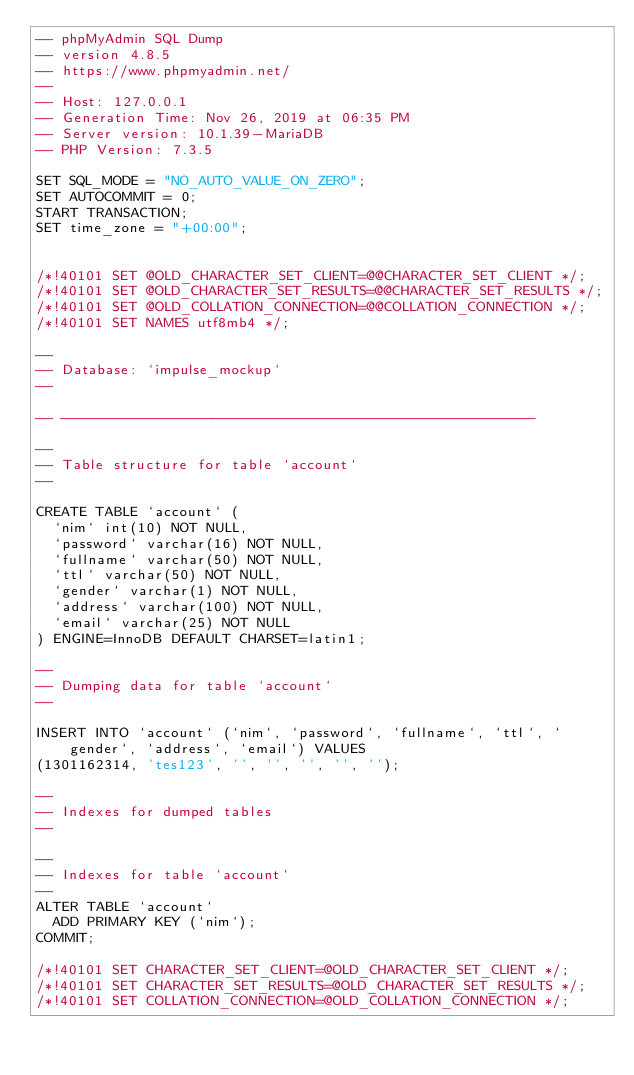<code> <loc_0><loc_0><loc_500><loc_500><_SQL_>-- phpMyAdmin SQL Dump
-- version 4.8.5
-- https://www.phpmyadmin.net/
--
-- Host: 127.0.0.1
-- Generation Time: Nov 26, 2019 at 06:35 PM
-- Server version: 10.1.39-MariaDB
-- PHP Version: 7.3.5

SET SQL_MODE = "NO_AUTO_VALUE_ON_ZERO";
SET AUTOCOMMIT = 0;
START TRANSACTION;
SET time_zone = "+00:00";


/*!40101 SET @OLD_CHARACTER_SET_CLIENT=@@CHARACTER_SET_CLIENT */;
/*!40101 SET @OLD_CHARACTER_SET_RESULTS=@@CHARACTER_SET_RESULTS */;
/*!40101 SET @OLD_COLLATION_CONNECTION=@@COLLATION_CONNECTION */;
/*!40101 SET NAMES utf8mb4 */;

--
-- Database: `impulse_mockup`
--

-- --------------------------------------------------------

--
-- Table structure for table `account`
--

CREATE TABLE `account` (
  `nim` int(10) NOT NULL,
  `password` varchar(16) NOT NULL,
  `fullname` varchar(50) NOT NULL,
  `ttl` varchar(50) NOT NULL,
  `gender` varchar(1) NOT NULL,
  `address` varchar(100) NOT NULL,
  `email` varchar(25) NOT NULL
) ENGINE=InnoDB DEFAULT CHARSET=latin1;

--
-- Dumping data for table `account`
--

INSERT INTO `account` (`nim`, `password`, `fullname`, `ttl`, `gender`, `address`, `email`) VALUES
(1301162314, 'tes123', '', '', '', '', '');

--
-- Indexes for dumped tables
--

--
-- Indexes for table `account`
--
ALTER TABLE `account`
  ADD PRIMARY KEY (`nim`);
COMMIT;

/*!40101 SET CHARACTER_SET_CLIENT=@OLD_CHARACTER_SET_CLIENT */;
/*!40101 SET CHARACTER_SET_RESULTS=@OLD_CHARACTER_SET_RESULTS */;
/*!40101 SET COLLATION_CONNECTION=@OLD_COLLATION_CONNECTION */;
</code> 